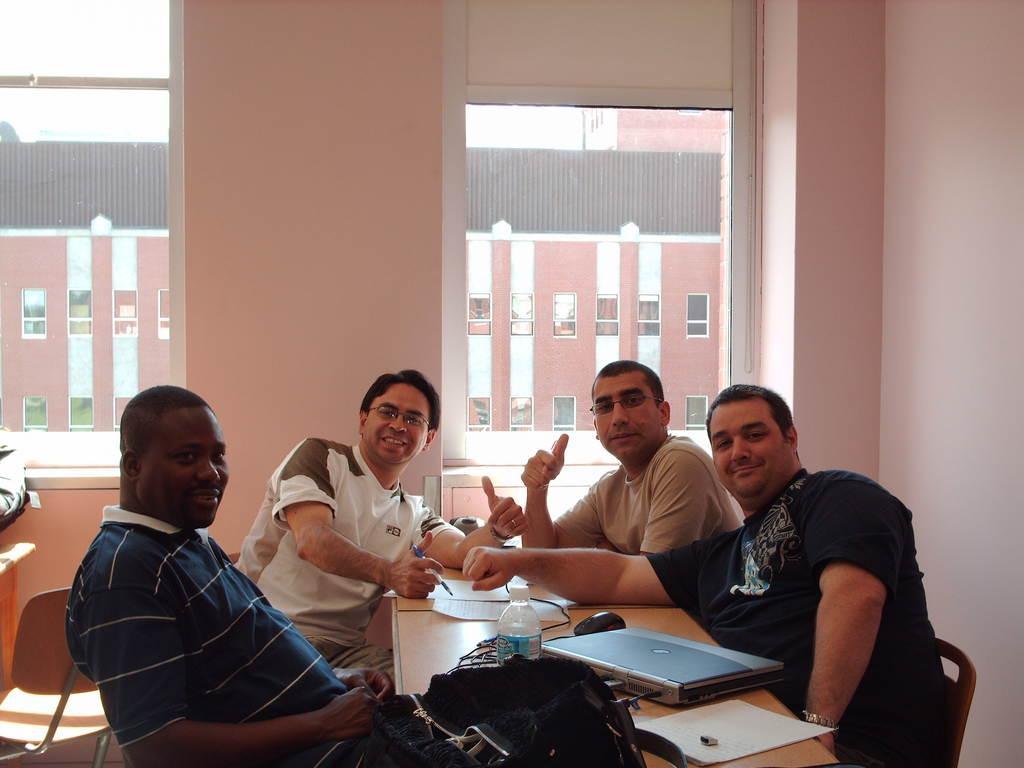In one or two sentences, can you explain what this image depicts? In this picture there are four man sitting on the chairs on the table on which there are some things placed like laptop,bottle and behind there are two Windows. 